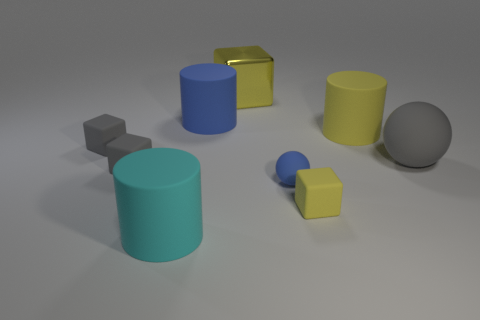Subtract all cyan matte cylinders. How many cylinders are left? 2 Subtract all brown balls. How many yellow blocks are left? 2 Add 1 small gray rubber objects. How many objects exist? 10 Subtract all red blocks. Subtract all yellow balls. How many blocks are left? 4 Subtract all spheres. How many objects are left? 7 Subtract all green metallic cubes. Subtract all blue rubber objects. How many objects are left? 7 Add 7 big metallic objects. How many big metallic objects are left? 8 Add 2 tiny purple shiny spheres. How many tiny purple shiny spheres exist? 2 Subtract 0 red blocks. How many objects are left? 9 